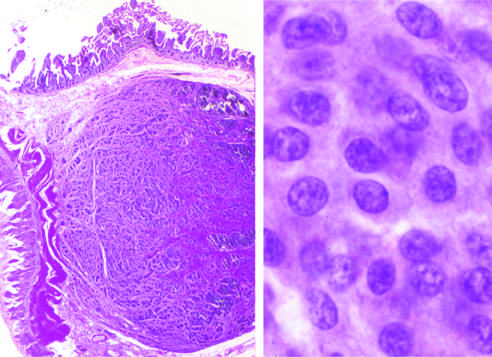does the chromatin texture, with fine and coarse clumps, assume a salt-and-pepper pattern?
Answer the question using a single word or phrase. Yes 